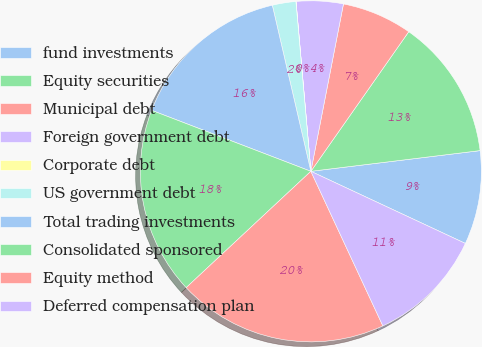Convert chart to OTSL. <chart><loc_0><loc_0><loc_500><loc_500><pie_chart><fcel>fund investments<fcel>Equity securities<fcel>Municipal debt<fcel>Foreign government debt<fcel>Corporate debt<fcel>US government debt<fcel>Total trading investments<fcel>Consolidated sponsored<fcel>Equity method<fcel>Deferred compensation plan<nl><fcel>8.89%<fcel>13.33%<fcel>6.67%<fcel>4.45%<fcel>0.01%<fcel>2.23%<fcel>15.55%<fcel>17.77%<fcel>19.99%<fcel>11.11%<nl></chart> 